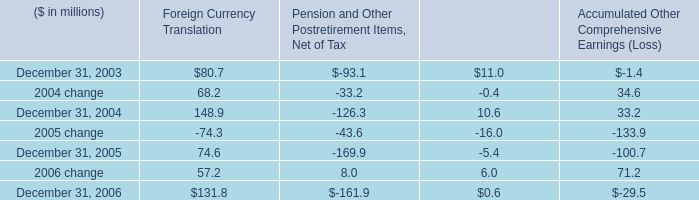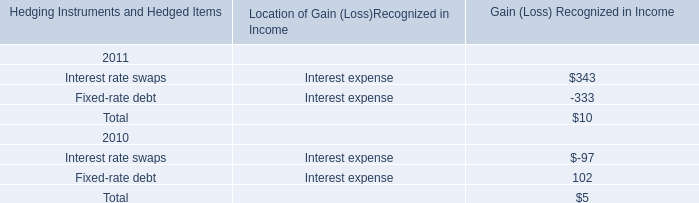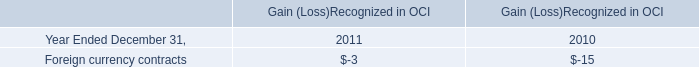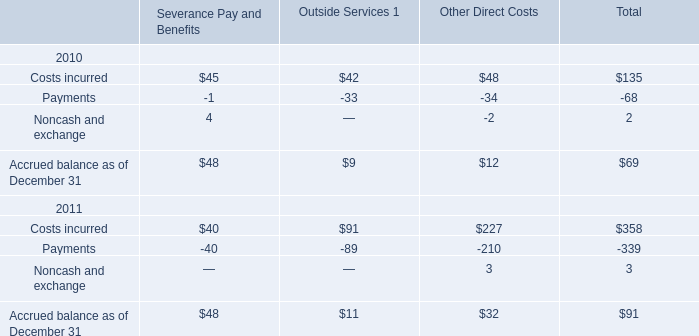what was the percentage reduction in the share repurchase program , from 2005 to 2006? 
Computations: ((358.1 - 45.7) / 358.1)
Answer: 0.87238. 